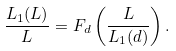<formula> <loc_0><loc_0><loc_500><loc_500>\frac { L _ { 1 } ( L ) } { L } = F _ { d } \left ( \frac { L } { L _ { 1 } ( d ) } \right ) .</formula> 